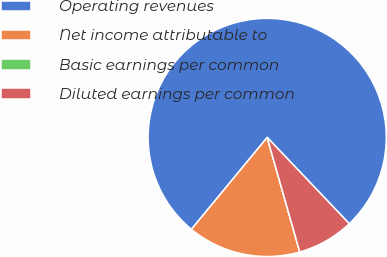Convert chart. <chart><loc_0><loc_0><loc_500><loc_500><pie_chart><fcel>Operating revenues<fcel>Net income attributable to<fcel>Basic earnings per common<fcel>Diluted earnings per common<nl><fcel>76.92%<fcel>15.39%<fcel>0.0%<fcel>7.69%<nl></chart> 